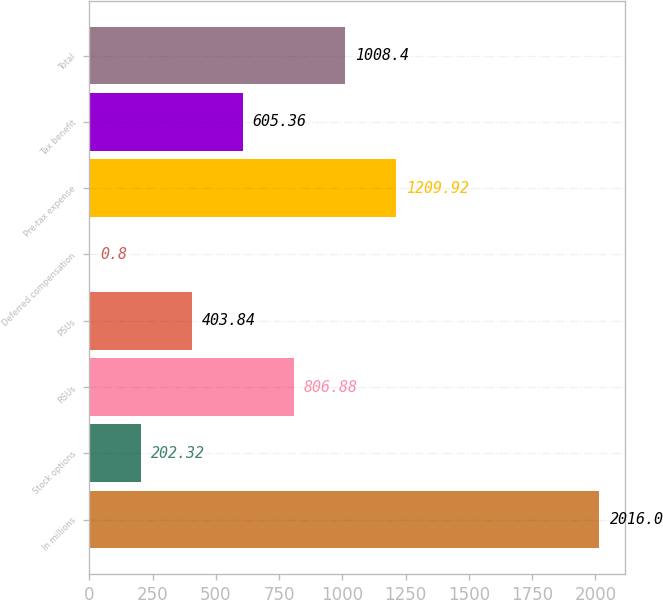Convert chart. <chart><loc_0><loc_0><loc_500><loc_500><bar_chart><fcel>In millions<fcel>Stock options<fcel>RSUs<fcel>PSUs<fcel>Deferred compensation<fcel>Pre-tax expense<fcel>Tax benefit<fcel>Total<nl><fcel>2016<fcel>202.32<fcel>806.88<fcel>403.84<fcel>0.8<fcel>1209.92<fcel>605.36<fcel>1008.4<nl></chart> 